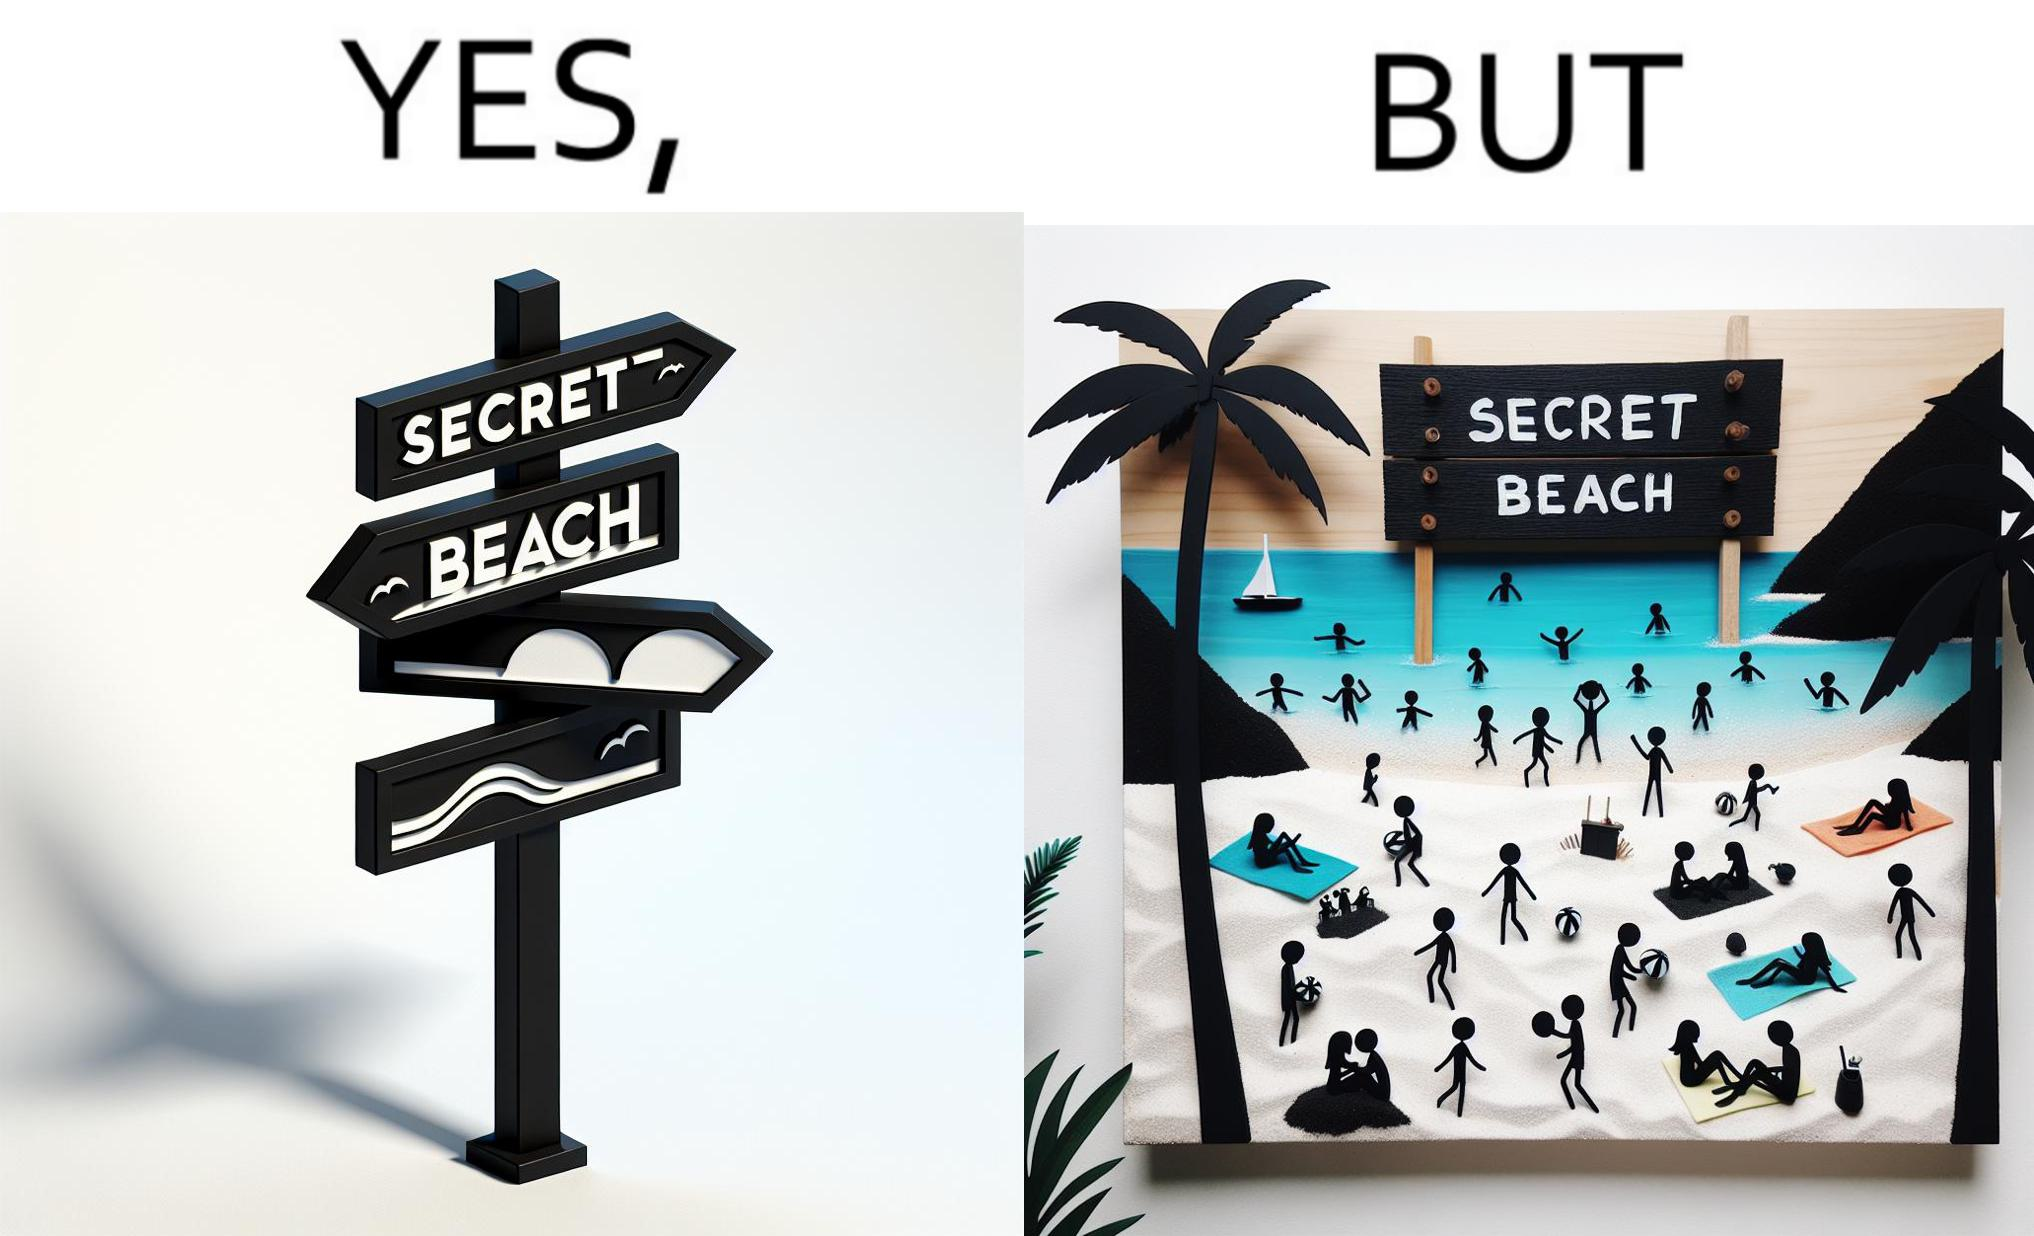Is this image satirical or non-satirical? Yes, this image is satirical. 